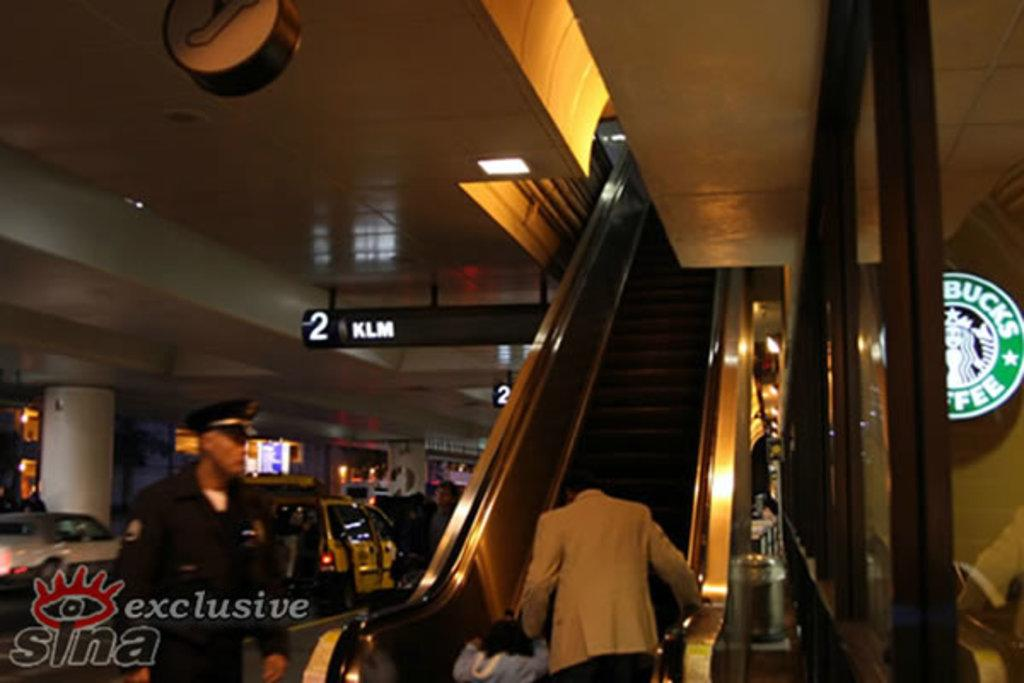<image>
Render a clear and concise summary of the photo. A black and white sign reads 2 KLM behind the escalator. 